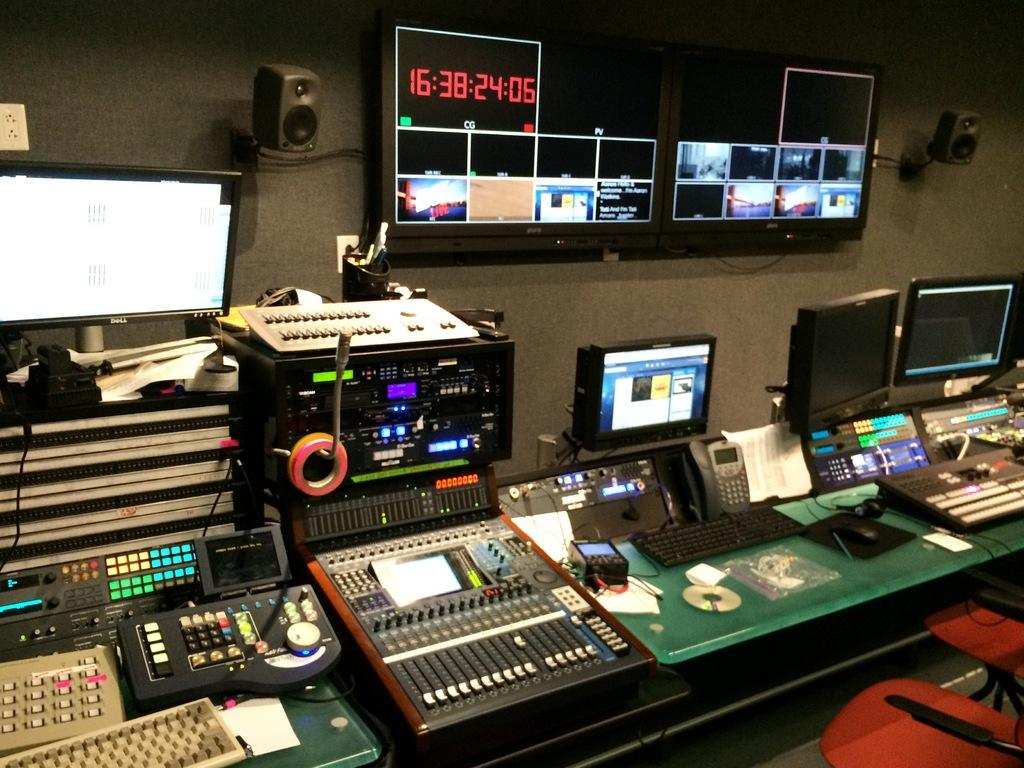Provide a one-sentence caption for the provided image. A timer that says 16:38:24:05 in red font. 